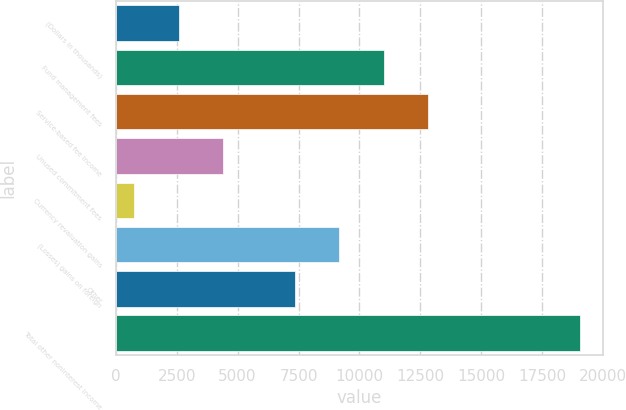<chart> <loc_0><loc_0><loc_500><loc_500><bar_chart><fcel>(Dollars in thousands)<fcel>Fund management fees<fcel>Service-based fee income<fcel>Unused commitment fees<fcel>Currency revaluation gains<fcel>(Losses) gains on foreign<fcel>Other<fcel>Total other noninterest income<nl><fcel>2582.9<fcel>10999.8<fcel>12829.7<fcel>4412.8<fcel>753<fcel>9169.9<fcel>7340<fcel>19052<nl></chart> 